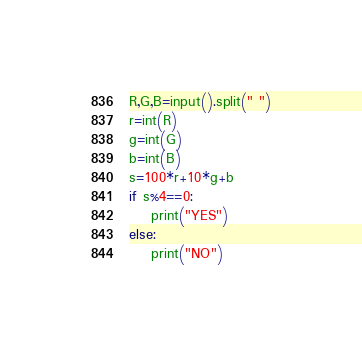Convert code to text. <code><loc_0><loc_0><loc_500><loc_500><_Python_>R,G,B=input().split(" ")
r=int(R)
g=int(G)
b=int(B)
s=100*r+10*g+b
if s%4==0:
    print("YES")
else:
    print("NO")</code> 